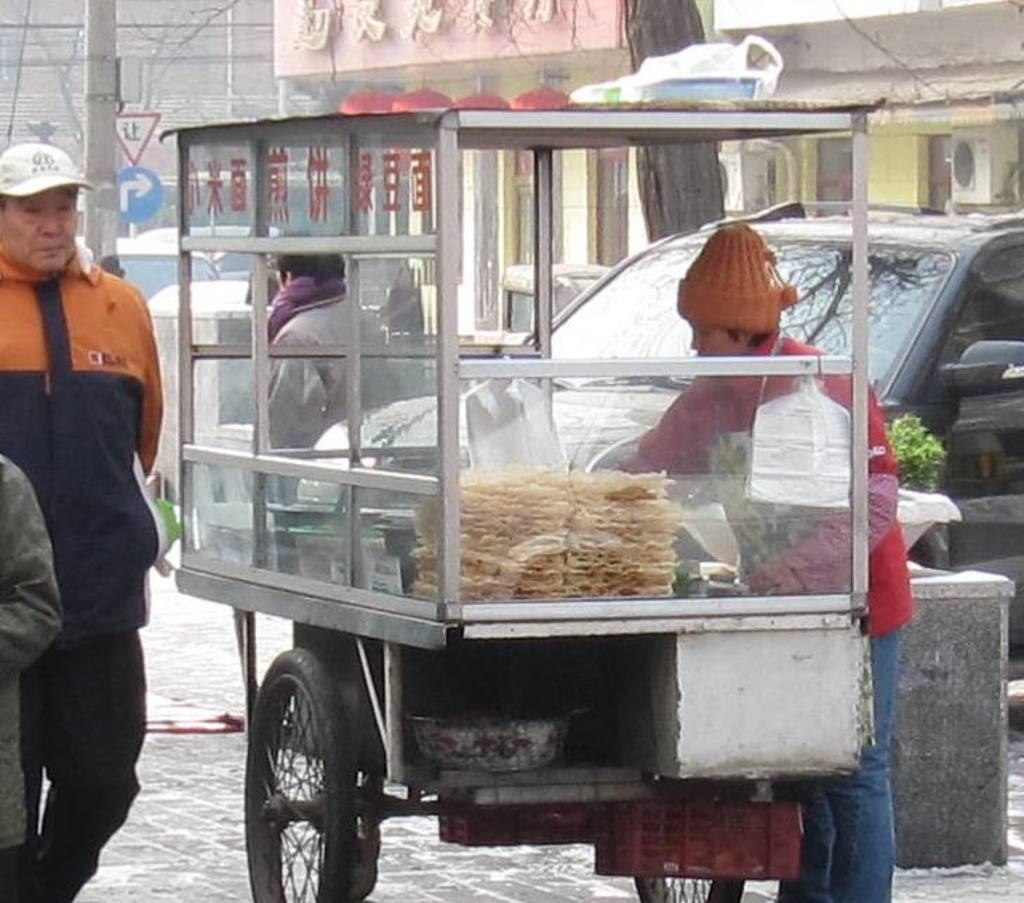What type of vehicle is present in the image? There is a food vehicle in the image. Can you describe the person's activity on the left side of the image? There is a person walking on the left side of the image. What else can be seen on the right side of the image? There is a car on the right side of the image. What type of liquid is being emitted from the pigs in the image? There are no pigs present in the image, so it is not possible to answer that question. 